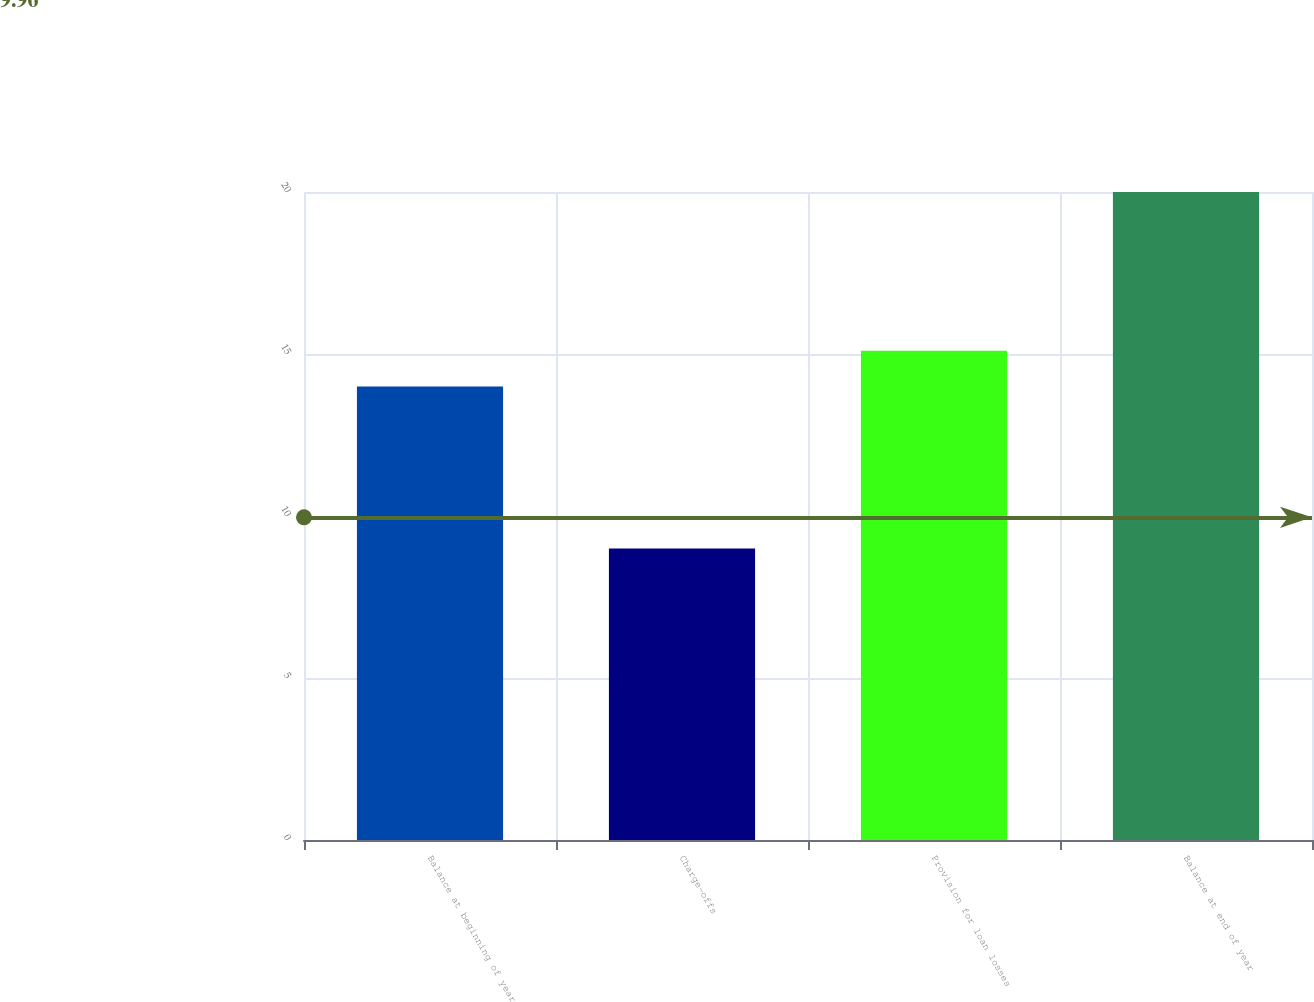<chart> <loc_0><loc_0><loc_500><loc_500><bar_chart><fcel>Balance at beginning of year<fcel>Charge-offs<fcel>Provision for loan losses<fcel>Balance at end of year<nl><fcel>14<fcel>9<fcel>15.1<fcel>20<nl></chart> 